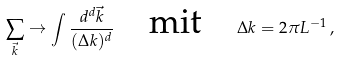Convert formula to latex. <formula><loc_0><loc_0><loc_500><loc_500>\sum _ { \vec { k } } \rightarrow \int \frac { d ^ { d } \vec { k } } { ( \Delta k ) ^ { d } } \quad \text {mit} \quad \Delta k = 2 \pi L ^ { - 1 } \, ,</formula> 